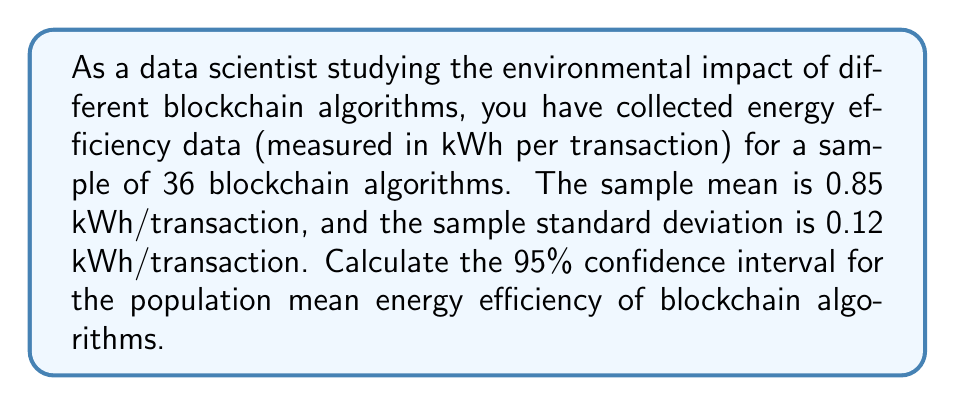Can you solve this math problem? To calculate the confidence interval for the population mean, we'll use the t-distribution since we don't know the population standard deviation. We'll follow these steps:

1. Identify the known values:
   - Sample size: $n = 36$
   - Sample mean: $\bar{x} = 0.85$ kWh/transaction
   - Sample standard deviation: $s = 0.12$ kWh/transaction
   - Confidence level: 95% (α = 0.05)

2. Calculate the standard error of the mean:
   $SE = \frac{s}{\sqrt{n}} = \frac{0.12}{\sqrt{36}} = 0.02$

3. Determine the degrees of freedom:
   $df = n - 1 = 36 - 1 = 35$

4. Find the t-critical value for a 95% confidence interval with 35 degrees of freedom:
   $t_{critical} = 2.030$ (from t-distribution table)

5. Calculate the margin of error:
   $ME = t_{critical} \times SE = 2.030 \times 0.02 = 0.0406$

6. Compute the confidence interval:
   Lower bound: $\bar{x} - ME = 0.85 - 0.0406 = 0.8094$
   Upper bound: $\bar{x} + ME = 0.85 + 0.0406 = 0.8906$

Therefore, the 95% confidence interval for the population mean energy efficiency is:

$$(0.8094, 0.8906)$$

This means we can be 95% confident that the true population mean energy efficiency of blockchain algorithms falls between 0.8094 and 0.8906 kWh per transaction.
Answer: The 95% confidence interval for the population mean energy efficiency of blockchain algorithms is (0.8094, 0.8906) kWh per transaction. 